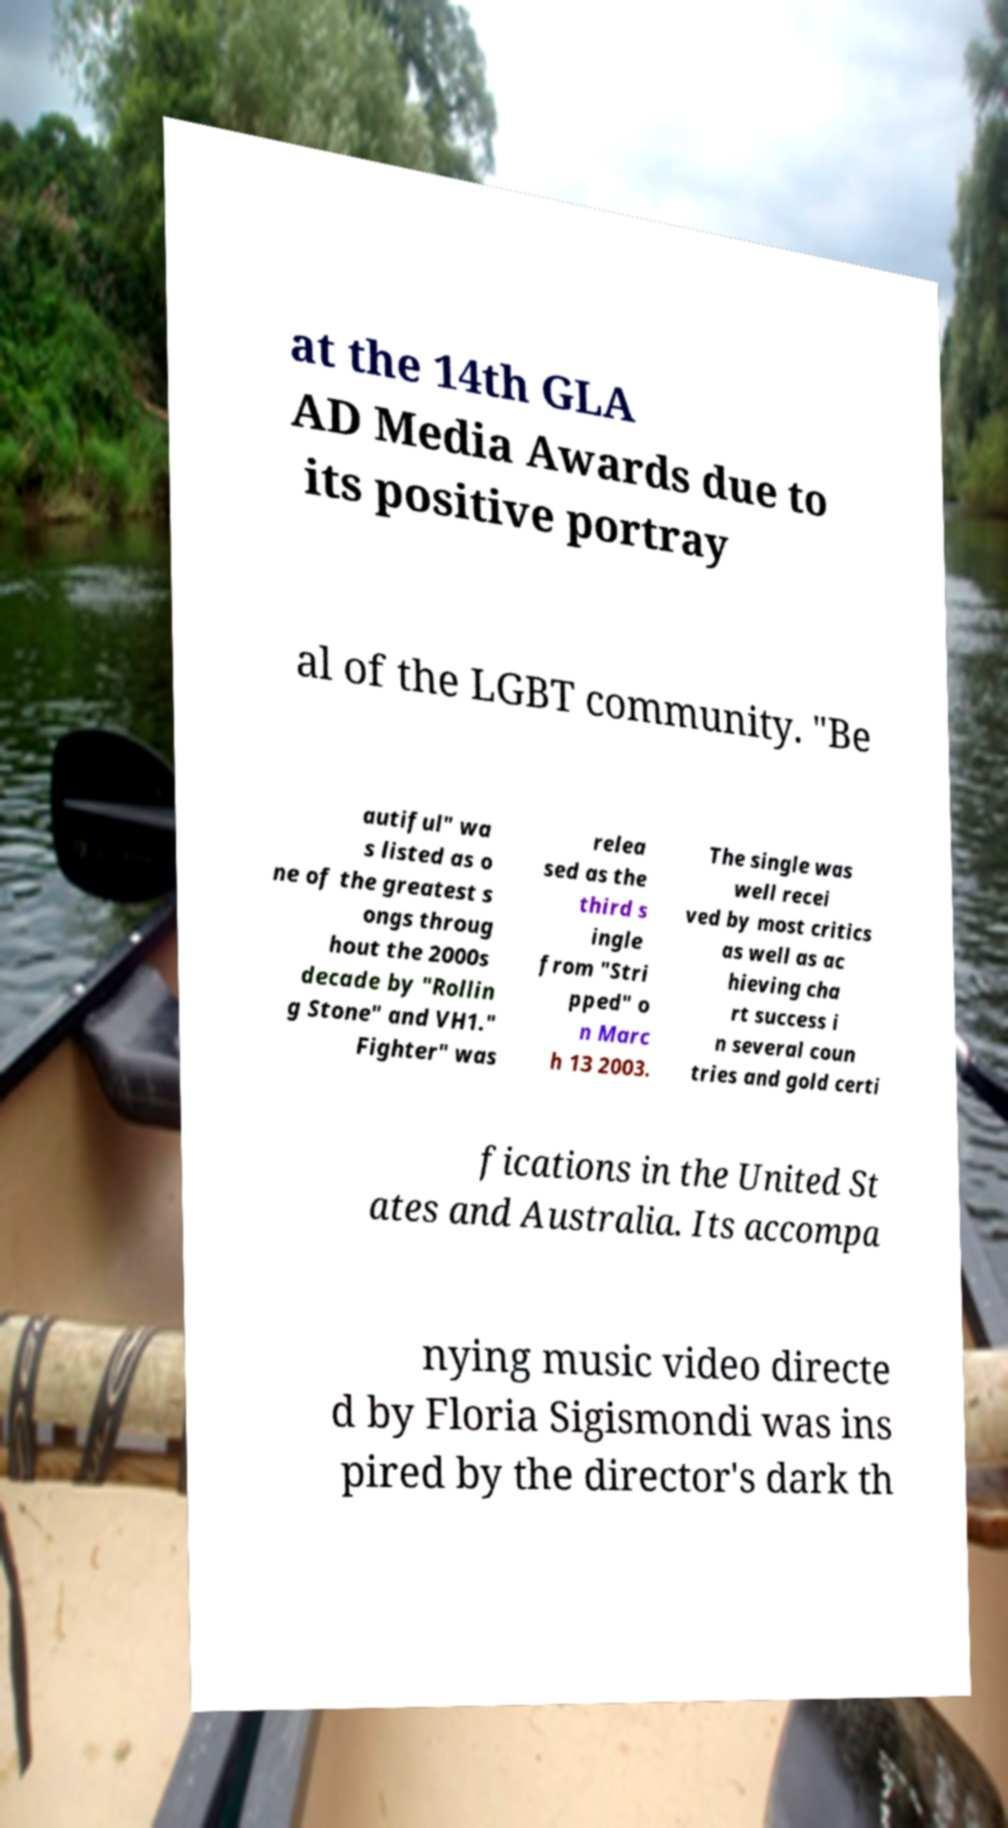Please read and relay the text visible in this image. What does it say? at the 14th GLA AD Media Awards due to its positive portray al of the LGBT community. "Be autiful" wa s listed as o ne of the greatest s ongs throug hout the 2000s decade by "Rollin g Stone" and VH1." Fighter" was relea sed as the third s ingle from "Stri pped" o n Marc h 13 2003. The single was well recei ved by most critics as well as ac hieving cha rt success i n several coun tries and gold certi fications in the United St ates and Australia. Its accompa nying music video directe d by Floria Sigismondi was ins pired by the director's dark th 